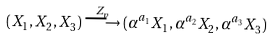Convert formula to latex. <formula><loc_0><loc_0><loc_500><loc_500>( X _ { 1 } , X _ { 2 } , X _ { 3 } ) \stackrel { Z _ { p } } { \longrightarrow } ( \alpha ^ { a _ { 1 } } X _ { 1 } , \alpha ^ { a _ { 2 } } X _ { 2 } , \alpha ^ { a _ { 3 } } X _ { 3 } )</formula> 